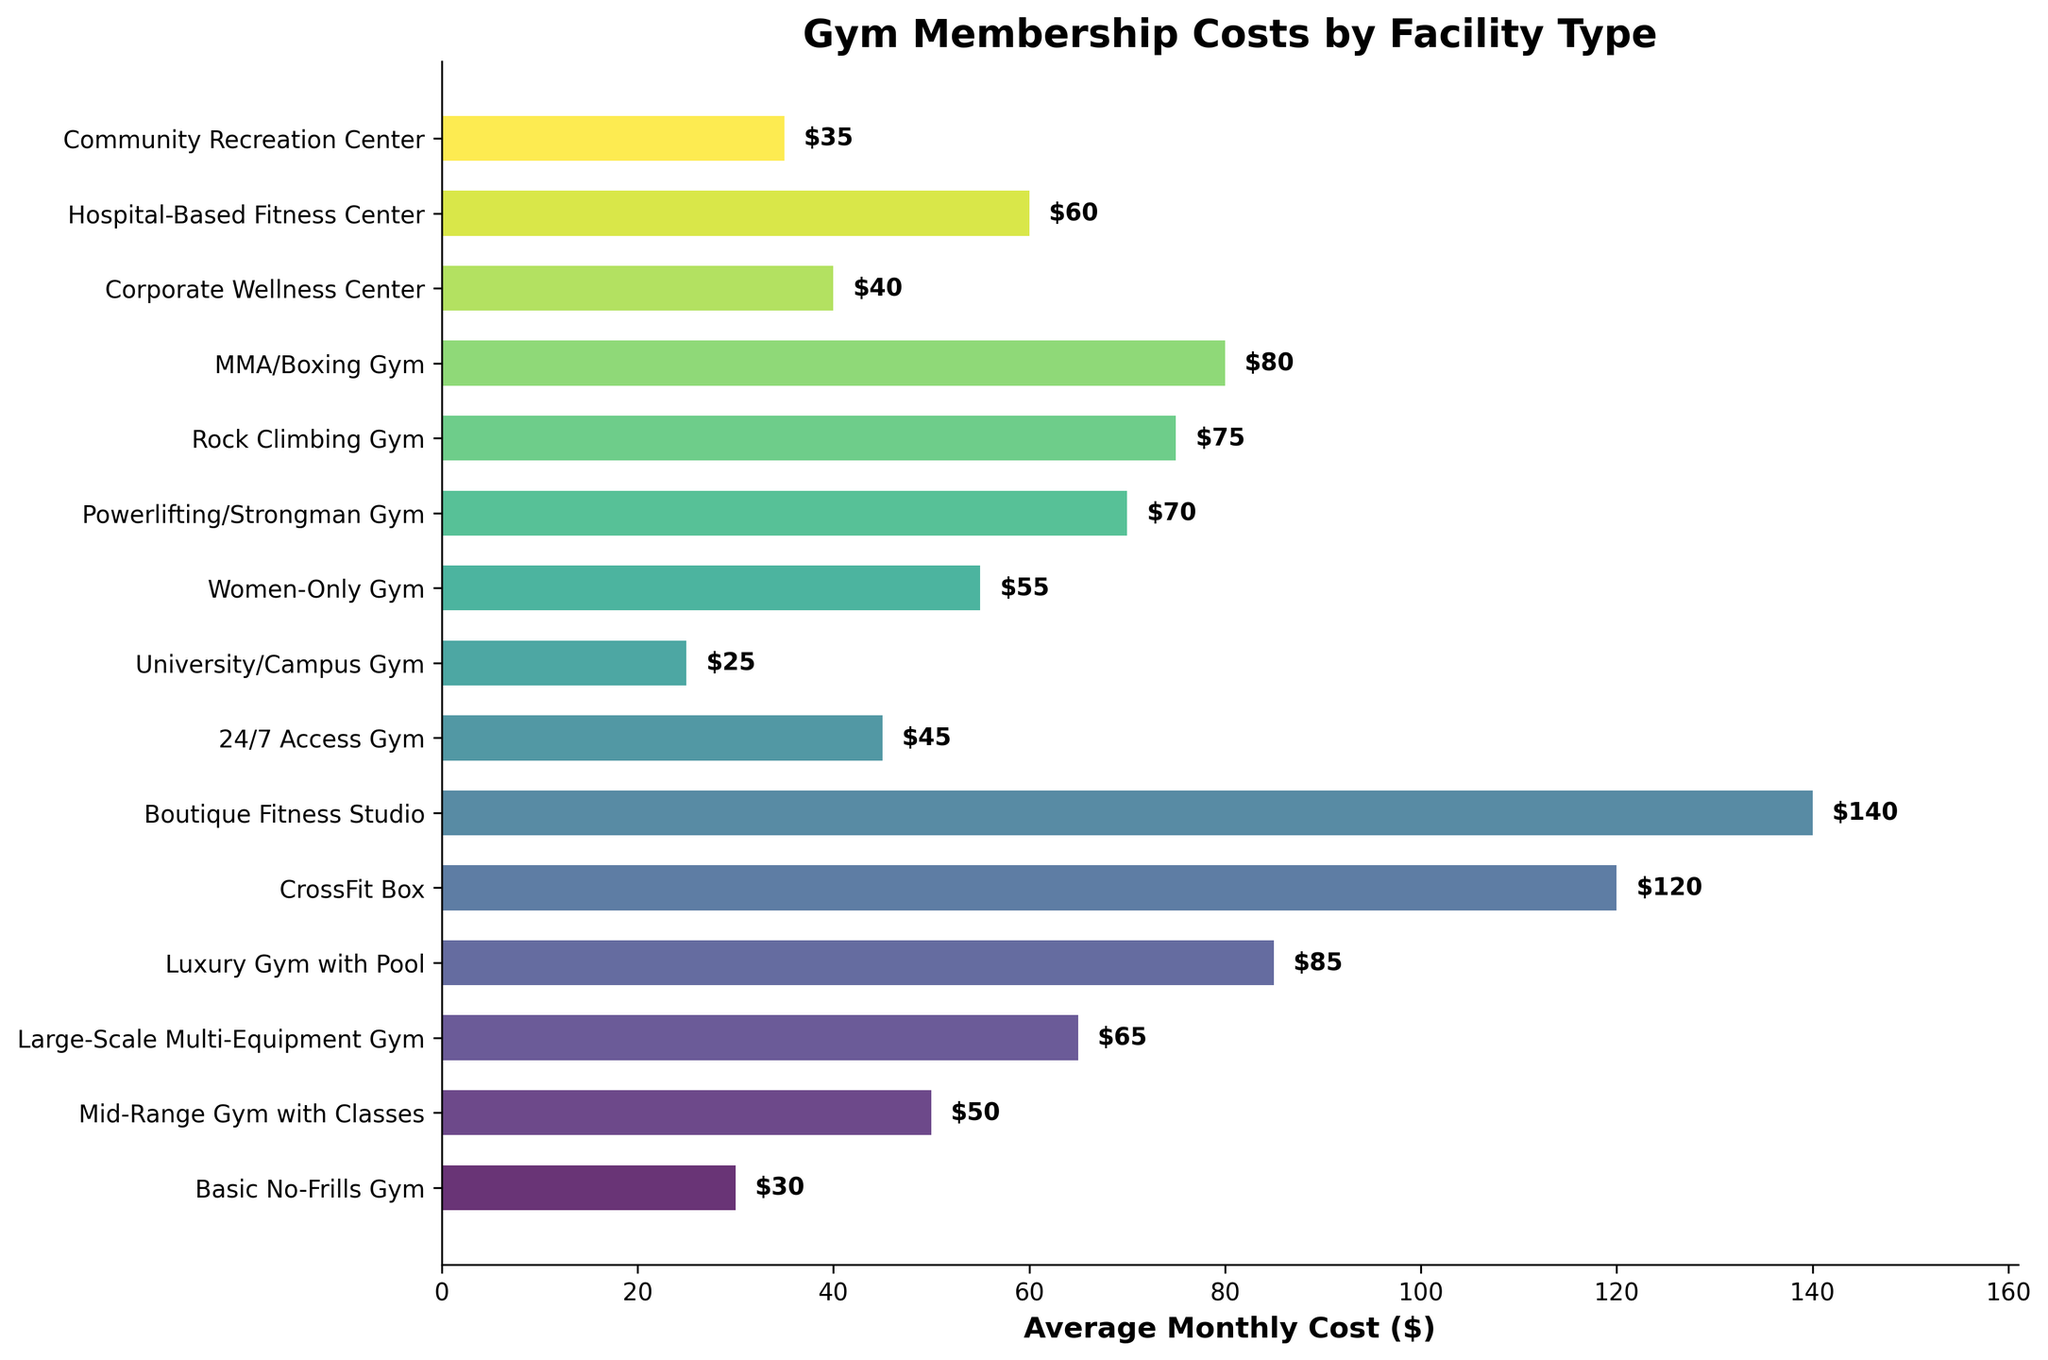Which facility type has the highest average monthly cost? The bar that extends the farthest to the right represents the facility type with the highest average monthly cost. According to the bar chart, the "Boutique Fitness Studio" has the highest average monthly cost.
Answer: Boutique Fitness Studio Which facility type has the lowest average monthly cost? The bar that extends the least to the right represents the facility type with the lowest average monthly cost. According to the bar chart, the "University/Campus Gym" has the lowest average monthly cost.
Answer: University/Campus Gym How much more expensive is a Boutique Fitness Studio than a Basic No-Frills Gym? To find the difference, you subtract the average monthly cost of the "Basic No-Frills Gym" ($30) from the "Boutique Fitness Studio" ($140). The calculation is $140 - $30.
Answer: $110 Which has a higher average monthly cost: MMA/Boxing Gym or Rock Climbing Gym? By comparing the lengths of the bars for "MMA/Boxing Gym" and "Rock Climbing Gym," we can see that the "MMA/Boxing Gym" bar extends slightly less far than the "Rock Climbing Gym" bar. Hence, Rock Climbing Gym is more expensive.
Answer: Rock Climbing Gym Are there any facility types with average monthly costs within $5 of each other? Comparing the lengths of the bars visually, "Women-Only Gym" ($55) and "Hospital-Based Fitness Center" ($60) have costs within $5 of each other.
Answer: Yes, Women-Only Gym and Hospital-Based Fitness Center What is the combined average monthly cost of a Corporate Wellness Center and a Community Recreation Center? To find the combined cost, add the average monthly cost of the "Corporate Wellness Center" ($40) and the "Community Recreation Center" ($35). The calculation is $40 + $35.
Answer: $75 On average, how much more does a Luxury Gym with Pool cost compared to a Mid-Range Gym with Classes? Subtract the average monthly cost of the "Mid-Range Gym with Classes" ($50) from the "Luxury Gym with Pool" ($85). The calculation is $85 - $50.
Answer: $35 Which facility types have average monthly costs greater than $70? By inspecting the bar lengths, the facility types with costs greater than $70 are "CrossFit Box" ($120), "Boutique Fitness Studio" ($140), "Rock Climbing Gym" ($75), "MMA/Boxing Gym" ($80), and "Powerlifting/Strongman Gym" ($70).
Answer: CrossFit Box, Boutique Fitness Studio, Rock Climbing Gym, MMA/Boxing Gym Which type of gym falls exactly in the middle of the provided cost range? Arrange the facility types by their average monthly costs and identify the median. The middle value in the sorted list is "Hospital-Based Fitness Center" ($60).
Answer: Hospital-Based Fitness Center 